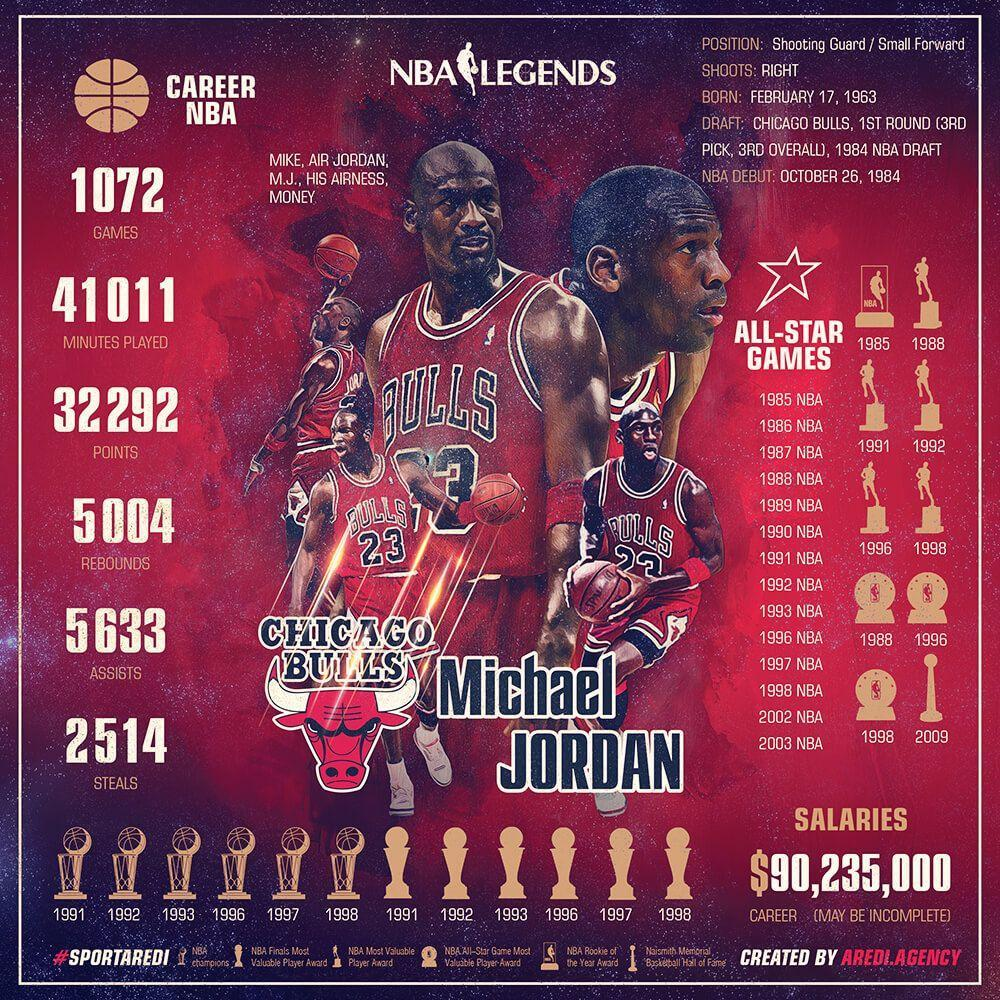How many years Michael Jordan got NBA Champions award?
Answer the question with a short phrase. 6 In which year Michael Jordan got the NBA Rookie of the year award? 1985 In which all years Michael Jordan got NBA All-Star Game Most valuable player award? 1988, 1996, 1998 How many years Michael Jordan got NBA Most valuable player award? 5 How many years Michael Jordan got the "NBA Finals most valuable player award"? 6 